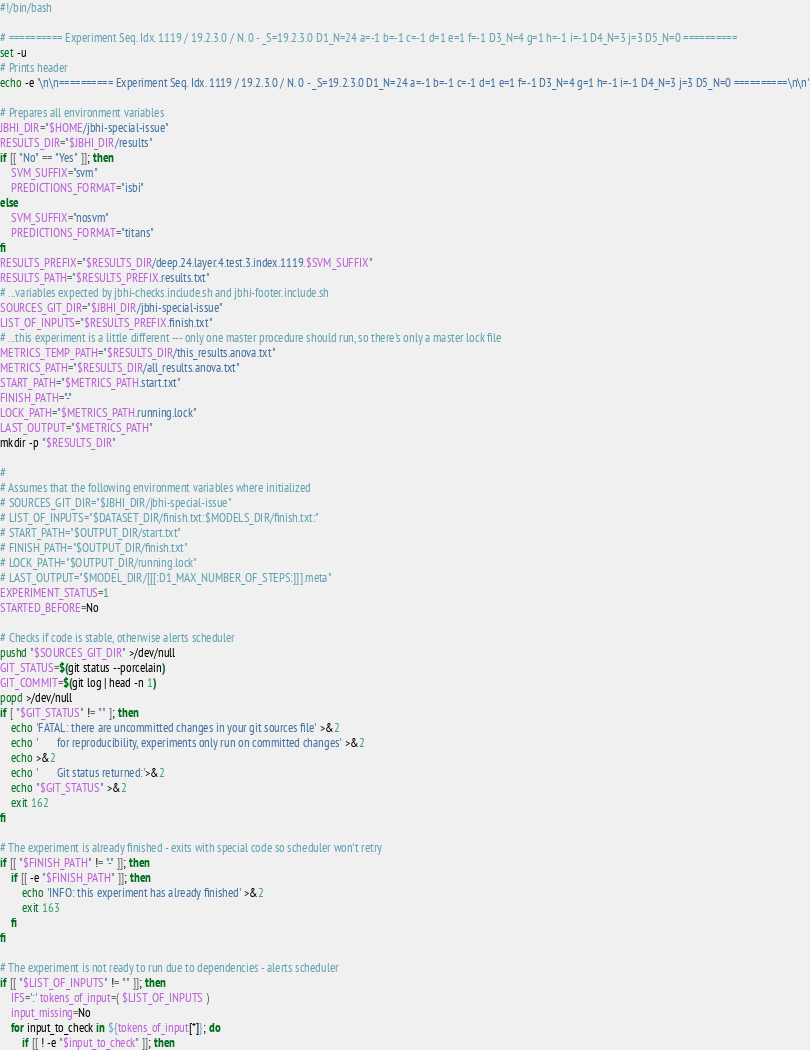<code> <loc_0><loc_0><loc_500><loc_500><_Bash_>#!/bin/bash

# ========== Experiment Seq. Idx. 1119 / 19.2.3.0 / N. 0 - _S=19.2.3.0 D1_N=24 a=-1 b=-1 c=-1 d=1 e=1 f=-1 D3_N=4 g=1 h=-1 i=-1 D4_N=3 j=3 D5_N=0 ==========
set -u
# Prints header
echo -e '\n\n========== Experiment Seq. Idx. 1119 / 19.2.3.0 / N. 0 - _S=19.2.3.0 D1_N=24 a=-1 b=-1 c=-1 d=1 e=1 f=-1 D3_N=4 g=1 h=-1 i=-1 D4_N=3 j=3 D5_N=0 ==========\n\n'

# Prepares all environment variables
JBHI_DIR="$HOME/jbhi-special-issue"
RESULTS_DIR="$JBHI_DIR/results"
if [[ "No" == "Yes" ]]; then
    SVM_SUFFIX="svm"
    PREDICTIONS_FORMAT="isbi"
else
    SVM_SUFFIX="nosvm"
    PREDICTIONS_FORMAT="titans"
fi
RESULTS_PREFIX="$RESULTS_DIR/deep.24.layer.4.test.3.index.1119.$SVM_SUFFIX"
RESULTS_PATH="$RESULTS_PREFIX.results.txt"
# ...variables expected by jbhi-checks.include.sh and jbhi-footer.include.sh
SOURCES_GIT_DIR="$JBHI_DIR/jbhi-special-issue"
LIST_OF_INPUTS="$RESULTS_PREFIX.finish.txt"
# ...this experiment is a little different --- only one master procedure should run, so there's only a master lock file
METRICS_TEMP_PATH="$RESULTS_DIR/this_results.anova.txt"
METRICS_PATH="$RESULTS_DIR/all_results.anova.txt"
START_PATH="$METRICS_PATH.start.txt"
FINISH_PATH="-"
LOCK_PATH="$METRICS_PATH.running.lock"
LAST_OUTPUT="$METRICS_PATH"
mkdir -p "$RESULTS_DIR"

#
# Assumes that the following environment variables where initialized
# SOURCES_GIT_DIR="$JBHI_DIR/jbhi-special-issue"
# LIST_OF_INPUTS="$DATASET_DIR/finish.txt:$MODELS_DIR/finish.txt:"
# START_PATH="$OUTPUT_DIR/start.txt"
# FINISH_PATH="$OUTPUT_DIR/finish.txt"
# LOCK_PATH="$OUTPUT_DIR/running.lock"
# LAST_OUTPUT="$MODEL_DIR/[[[:D1_MAX_NUMBER_OF_STEPS:]]].meta"
EXPERIMENT_STATUS=1
STARTED_BEFORE=No

# Checks if code is stable, otherwise alerts scheduler
pushd "$SOURCES_GIT_DIR" >/dev/null
GIT_STATUS=$(git status --porcelain)
GIT_COMMIT=$(git log | head -n 1)
popd >/dev/null
if [ "$GIT_STATUS" != "" ]; then
    echo 'FATAL: there are uncommitted changes in your git sources file' >&2
    echo '       for reproducibility, experiments only run on committed changes' >&2
    echo >&2
    echo '       Git status returned:'>&2
    echo "$GIT_STATUS" >&2
    exit 162
fi

# The experiment is already finished - exits with special code so scheduler won't retry
if [[ "$FINISH_PATH" != "-" ]]; then
    if [[ -e "$FINISH_PATH" ]]; then
        echo 'INFO: this experiment has already finished' >&2
        exit 163
    fi
fi

# The experiment is not ready to run due to dependencies - alerts scheduler
if [[ "$LIST_OF_INPUTS" != "" ]]; then
    IFS=':' tokens_of_input=( $LIST_OF_INPUTS )
    input_missing=No
    for input_to_check in ${tokens_of_input[*]}; do
        if [[ ! -e "$input_to_check" ]]; then</code> 